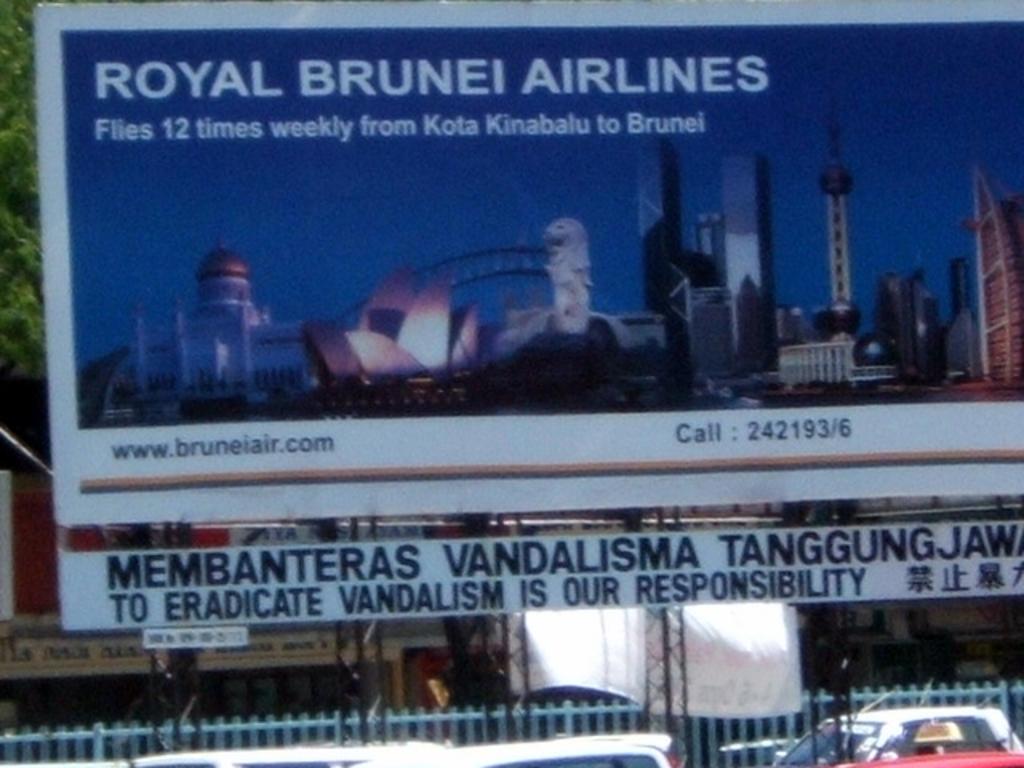What phone number should you call?
Your answer should be very brief. 242193/6. Royal brunei what?
Provide a succinct answer. Airlines. 